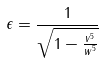<formula> <loc_0><loc_0><loc_500><loc_500>\epsilon = \frac { 1 } { \sqrt { 1 - \frac { v ^ { 5 } } { w ^ { 5 } } } }</formula> 